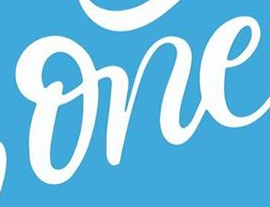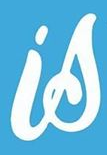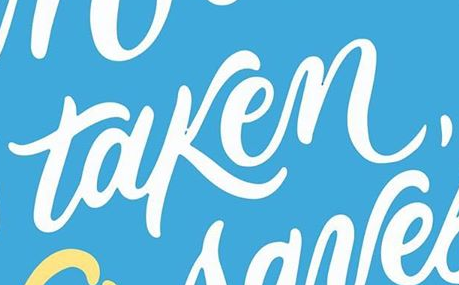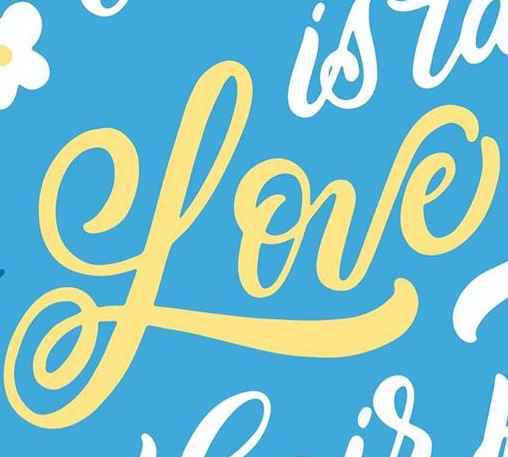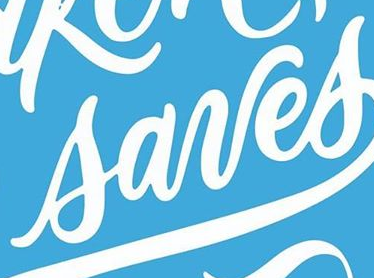What text is displayed in these images sequentially, separated by a semicolon? one; is; taken,; Love; sanes 